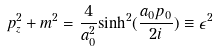<formula> <loc_0><loc_0><loc_500><loc_500>p _ { z } ^ { 2 } + m ^ { 2 } = \frac { 4 } { a _ { 0 } ^ { 2 } } { \sinh } ^ { 2 } ( \frac { a _ { 0 } p _ { 0 } } { 2 i } ) \equiv \epsilon ^ { 2 }</formula> 